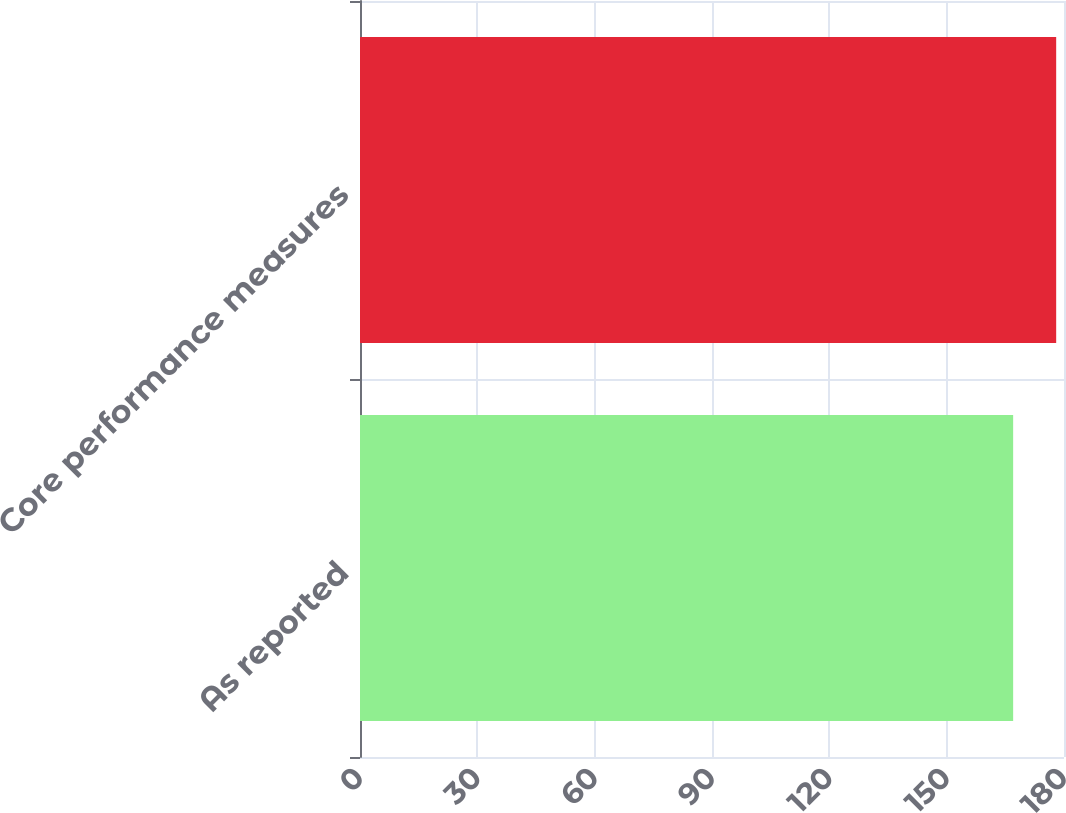Convert chart. <chart><loc_0><loc_0><loc_500><loc_500><bar_chart><fcel>As reported<fcel>Core performance measures<nl><fcel>167<fcel>178<nl></chart> 